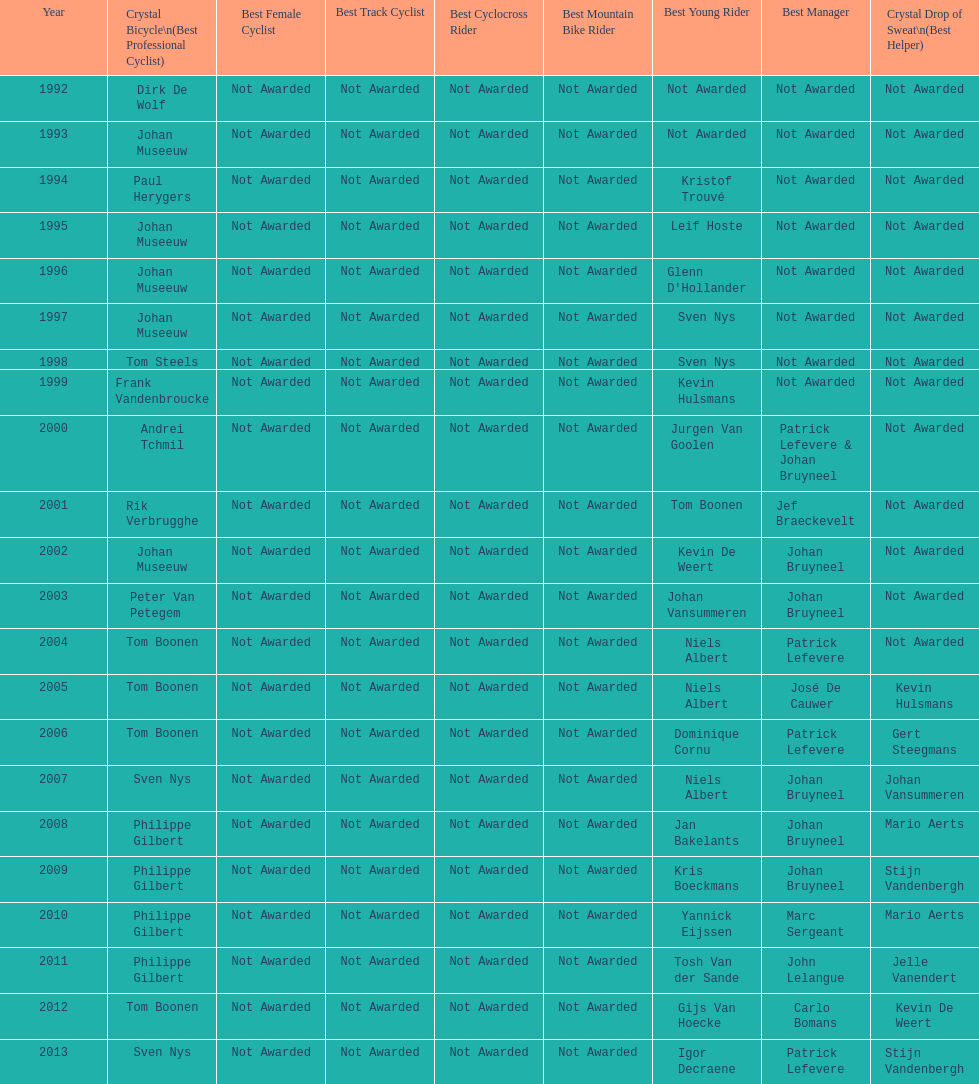What is the total number of times johan bryneel's name appears on all of these lists? 6. 